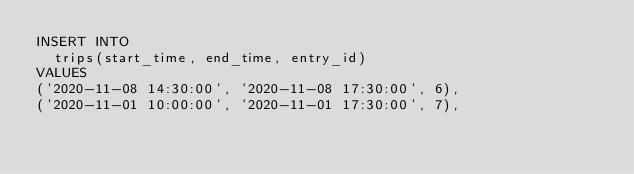Convert code to text. <code><loc_0><loc_0><loc_500><loc_500><_SQL_>INSERT INTO
  trips(start_time, end_time, entry_id)
VALUES
('2020-11-08 14:30:00', '2020-11-08 17:30:00', 6),
('2020-11-01 10:00:00', '2020-11-01 17:30:00', 7),</code> 